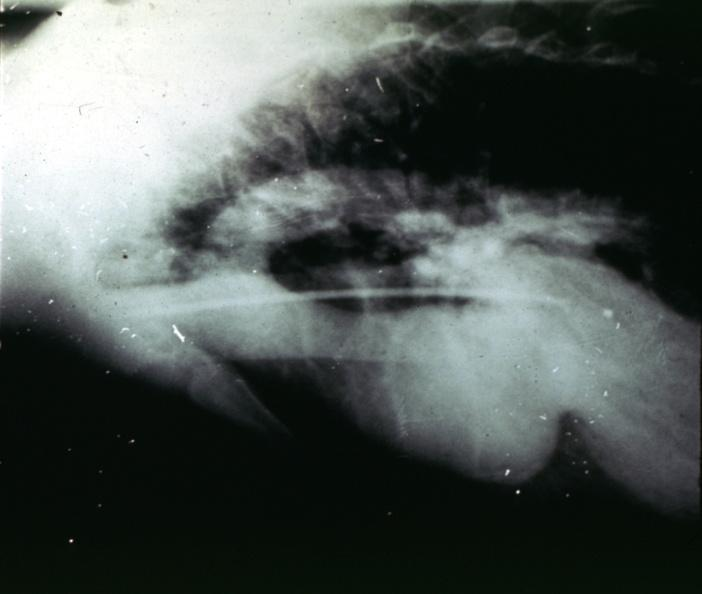what is present?
Answer the question using a single word or phrase. Aorta 